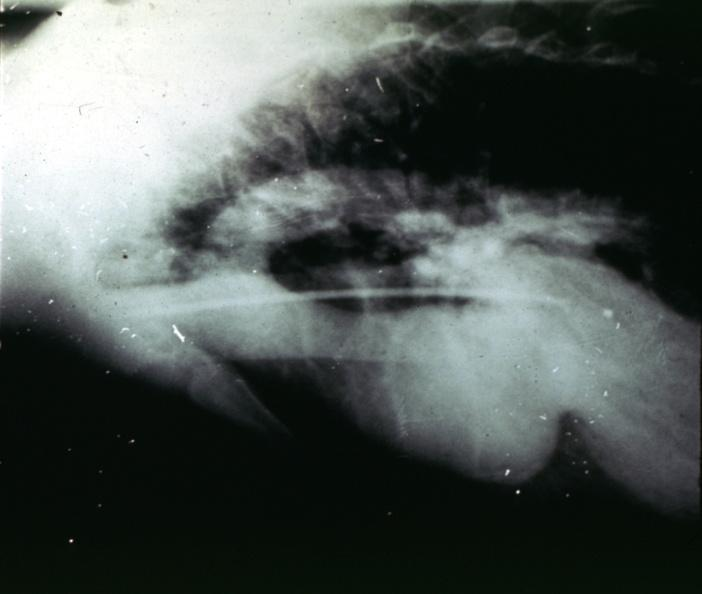what is present?
Answer the question using a single word or phrase. Aorta 